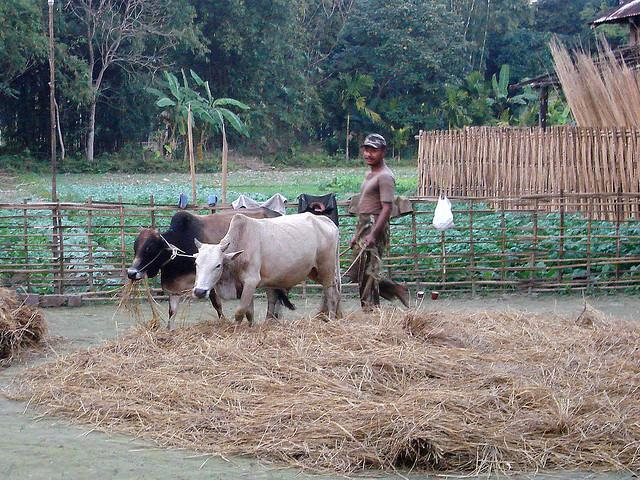What keeps the cattle from eating the garden here?

Choices:
A) man
B) fencing
C) nothing
D) fear fencing 